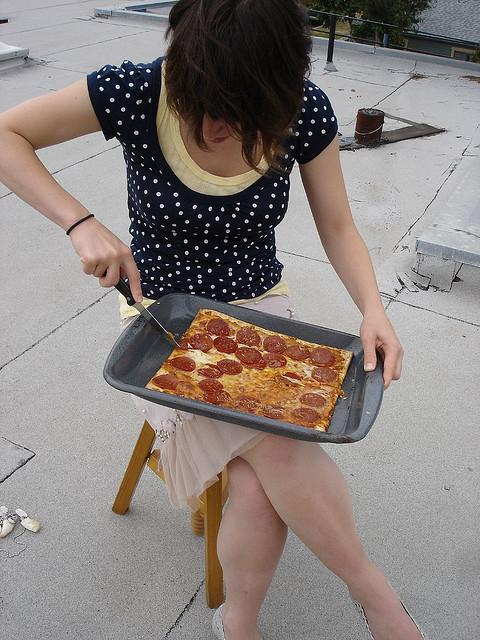What is different about this pizza than most pizzas? Please explain your reasoning. square shape. The pizza is not in its regular round shape but is shaped like a box. 